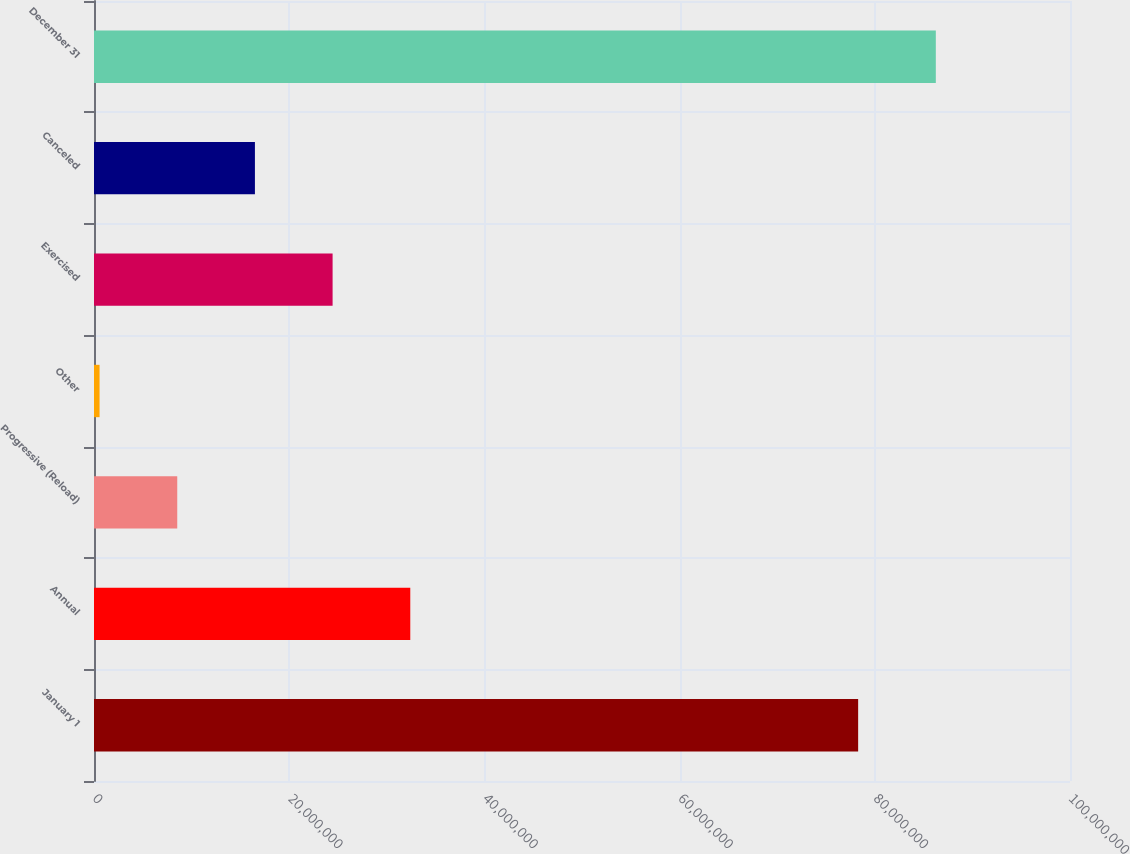Convert chart. <chart><loc_0><loc_0><loc_500><loc_500><bar_chart><fcel>January 1<fcel>Annual<fcel>Progressive (Reload)<fcel>Other<fcel>Exercised<fcel>Canceled<fcel>December 31<nl><fcel>7.82938e+07<fcel>3.24055e+07<fcel>8.52934e+06<fcel>570631<fcel>2.44468e+07<fcel>1.6488e+07<fcel>8.62525e+07<nl></chart> 